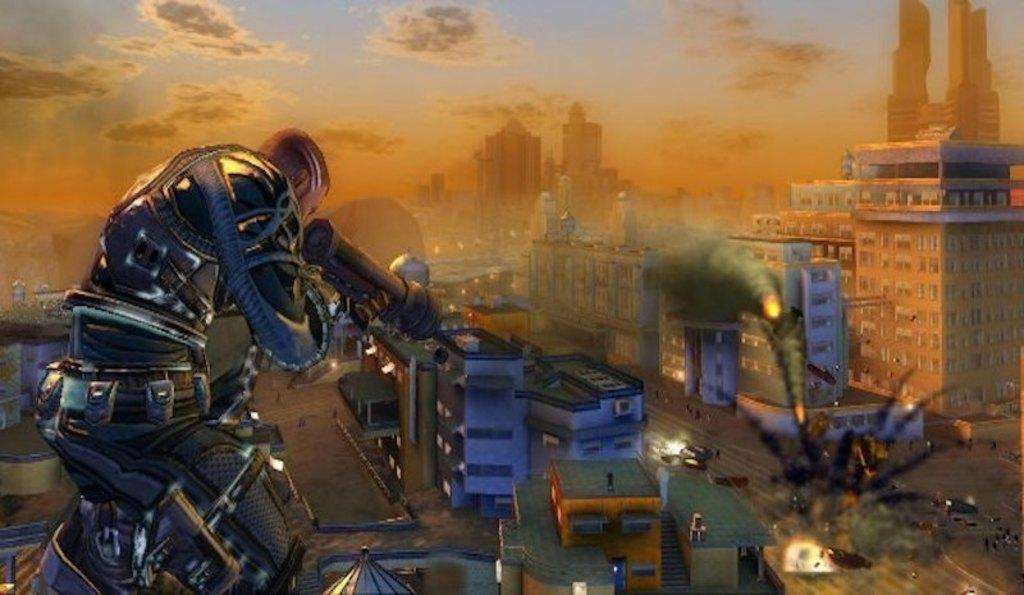What type of picture is in the image? The image contains a cartoon picture. What is the man in the image holding? The man is holding a gun in the image. What can be seen in the background of the image? There are buildings visible in the image. What is happening in the image that involves smoke and fire? Smoke and fire are present in the image. How would you describe the weather based on the sky in the image? The sky is cloudy in the image. What is the value of the skate in the image? There is no skate present in the image, so it is not possible to determine its value. 